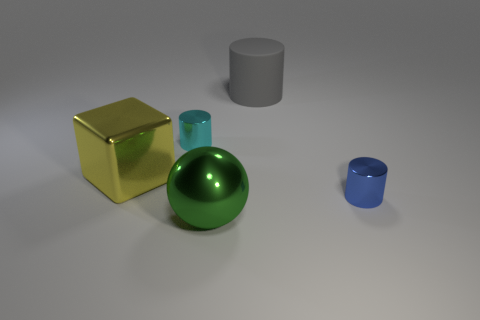There is a matte thing; is its size the same as the object that is on the left side of the cyan object?
Your answer should be very brief. Yes. How many blocks are either big things or tiny blue metallic things?
Keep it short and to the point. 1. There is a blue cylinder that is the same material as the ball; what size is it?
Provide a short and direct response. Small. There is a metal sphere that is in front of the big rubber cylinder; is it the same size as the block behind the large green ball?
Your answer should be compact. Yes. What number of things are tiny red blocks or big balls?
Offer a very short reply. 1. The rubber object is what shape?
Your answer should be compact. Cylinder. What size is the blue metal object that is the same shape as the small cyan object?
Your answer should be very brief. Small. Is there any other thing that has the same material as the cube?
Offer a terse response. Yes. How big is the metallic cylinder left of the tiny metallic cylinder on the right side of the large gray matte cylinder?
Provide a short and direct response. Small. Are there the same number of blue metallic cylinders left of the ball and blocks?
Give a very brief answer. No. 